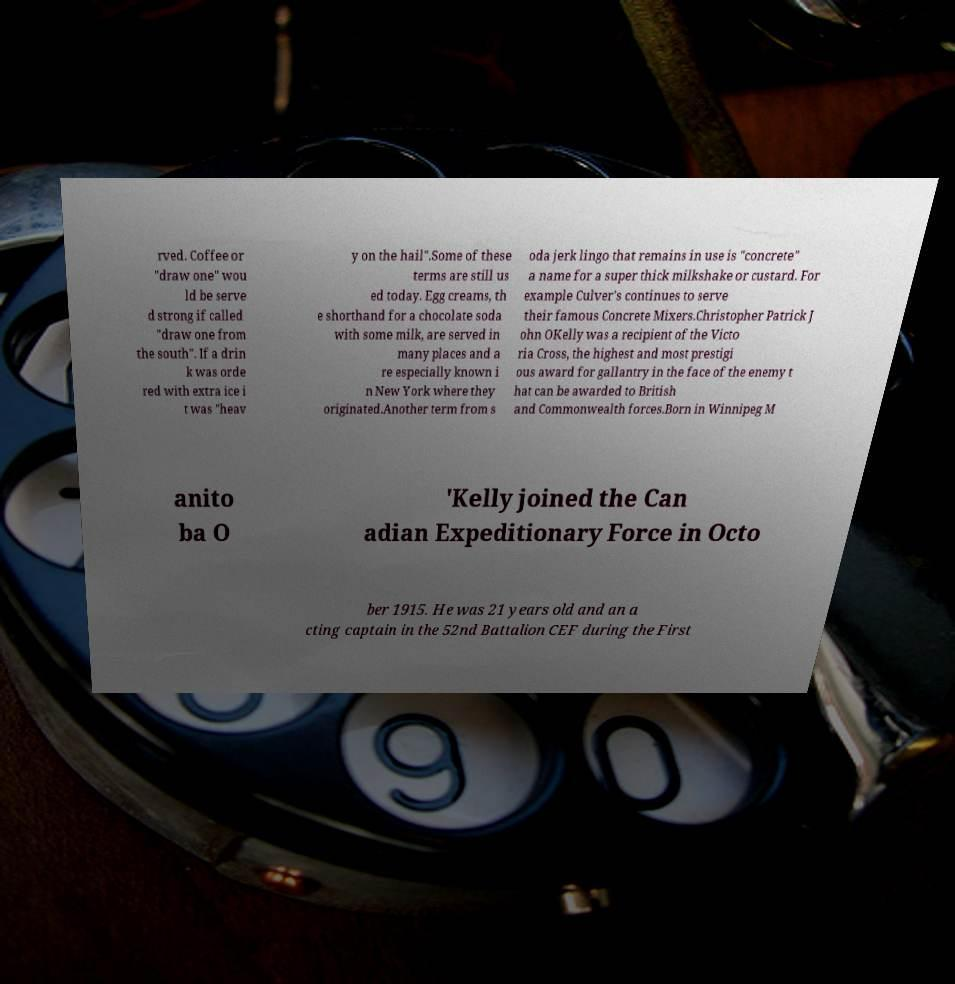What messages or text are displayed in this image? I need them in a readable, typed format. rved. Coffee or "draw one" wou ld be serve d strong if called "draw one from the south". If a drin k was orde red with extra ice i t was "heav y on the hail".Some of these terms are still us ed today. Egg creams, th e shorthand for a chocolate soda with some milk, are served in many places and a re especially known i n New York where they originated.Another term from s oda jerk lingo that remains in use is "concrete" a name for a super thick milkshake or custard. For example Culver's continues to serve their famous Concrete Mixers.Christopher Patrick J ohn OKelly was a recipient of the Victo ria Cross, the highest and most prestigi ous award for gallantry in the face of the enemy t hat can be awarded to British and Commonwealth forces.Born in Winnipeg M anito ba O 'Kelly joined the Can adian Expeditionary Force in Octo ber 1915. He was 21 years old and an a cting captain in the 52nd Battalion CEF during the First 